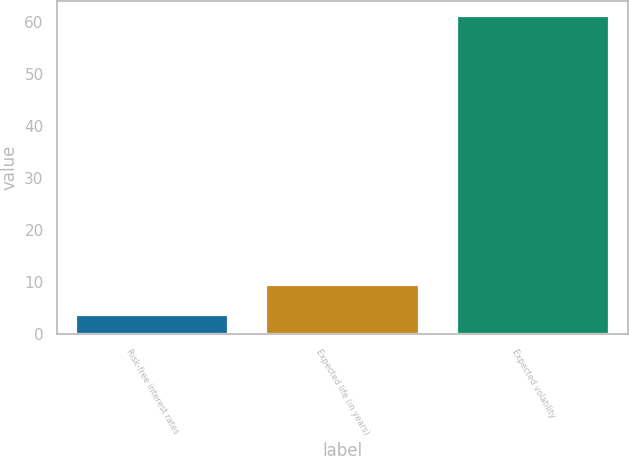Convert chart. <chart><loc_0><loc_0><loc_500><loc_500><bar_chart><fcel>Risk-free interest rates<fcel>Expected life (in years)<fcel>Expected volatility<nl><fcel>3.7<fcel>9.43<fcel>61<nl></chart> 